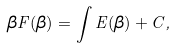Convert formula to latex. <formula><loc_0><loc_0><loc_500><loc_500>\beta F ( \beta ) = \int E ( \beta ) + C ,</formula> 